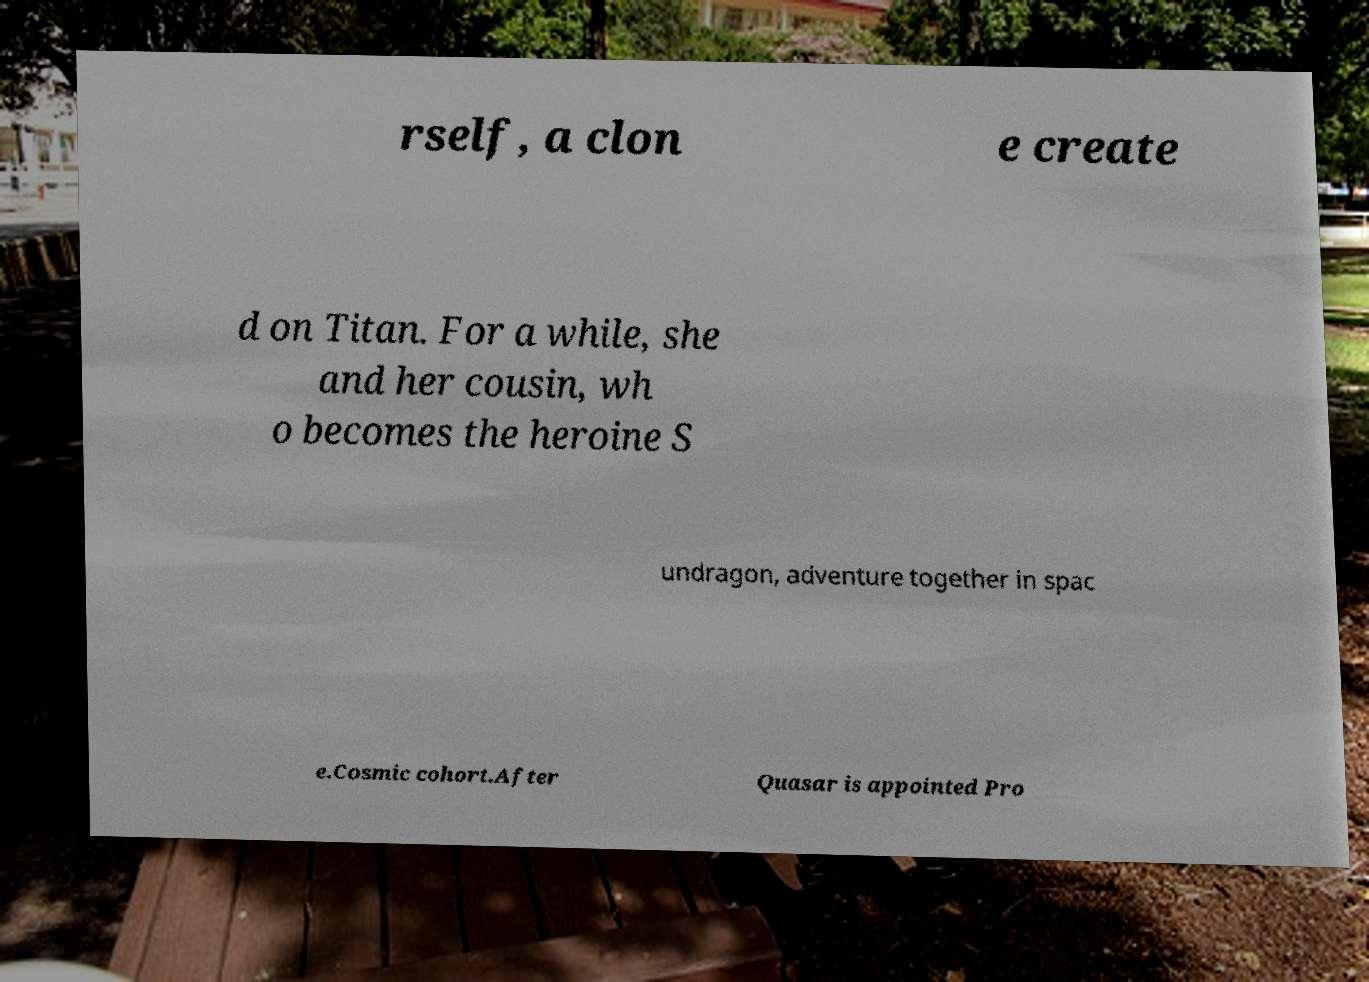Could you extract and type out the text from this image? rself, a clon e create d on Titan. For a while, she and her cousin, wh o becomes the heroine S undragon, adventure together in spac e.Cosmic cohort.After Quasar is appointed Pro 